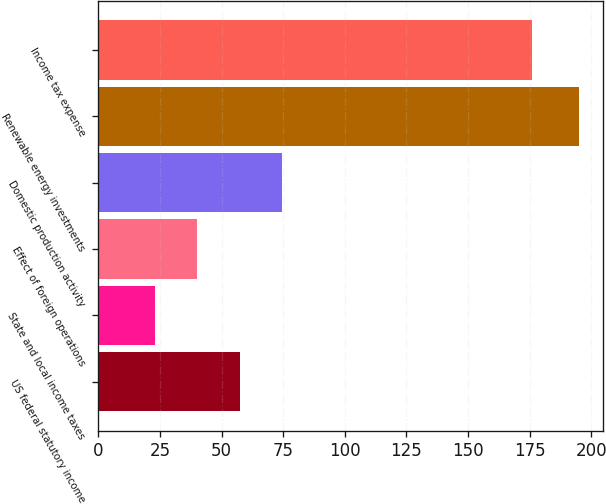Convert chart to OTSL. <chart><loc_0><loc_0><loc_500><loc_500><bar_chart><fcel>US federal statutory income<fcel>State and local income taxes<fcel>Effect of foreign operations<fcel>Domestic production activity<fcel>Renewable energy investments<fcel>Income tax expense<nl><fcel>57.4<fcel>23<fcel>40.2<fcel>74.6<fcel>195<fcel>176<nl></chart> 